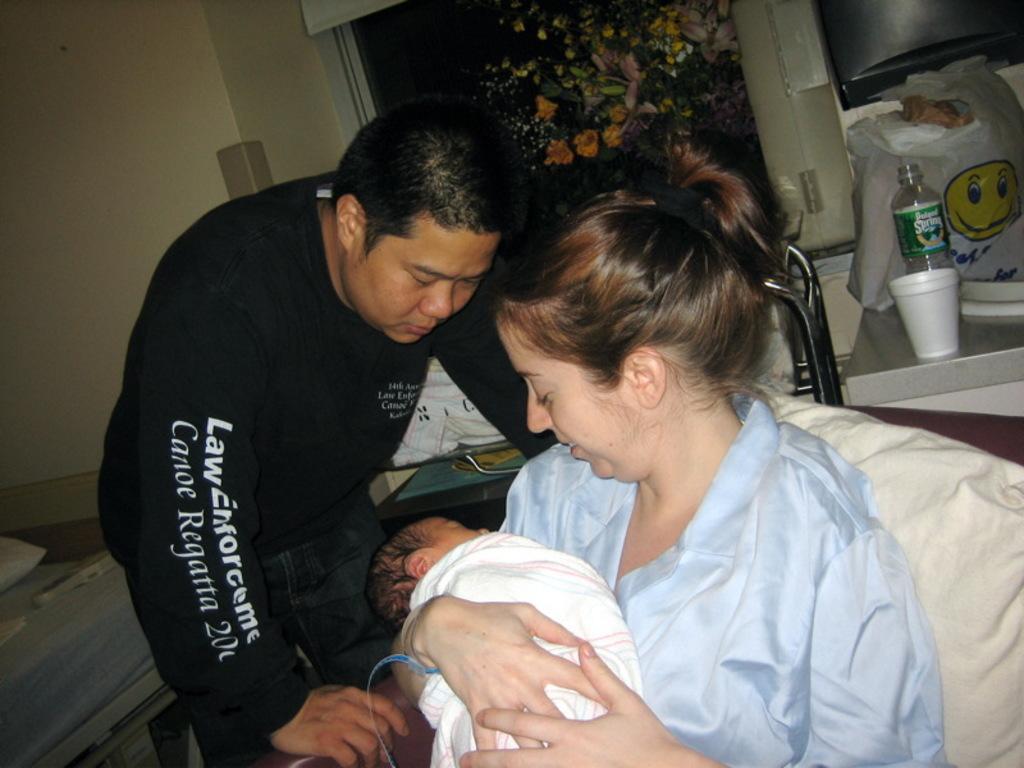Could you give a brief overview of what you see in this image? In the foreground I can see a woman is holding a baby in her hand is sitting on a sofa and a person. In the background I can see a table, cushion, wall, window, some objects on the table and a houseplant. This image is taken may be in a hall. 